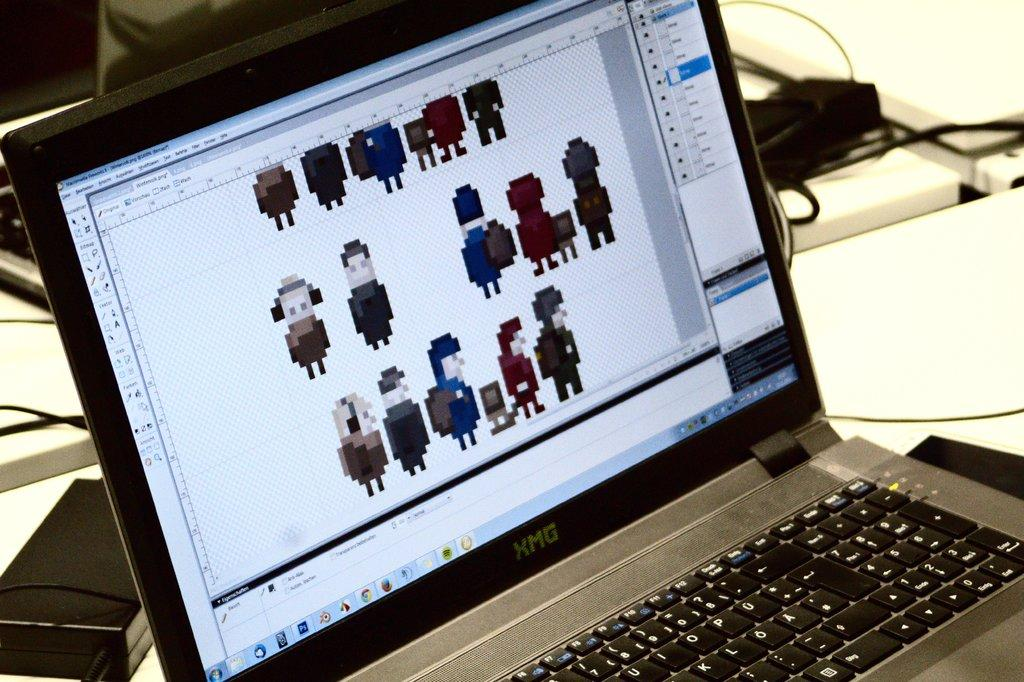<image>
Write a terse but informative summary of the picture. An opened XMG laptop shows some highly pixelated characters. 